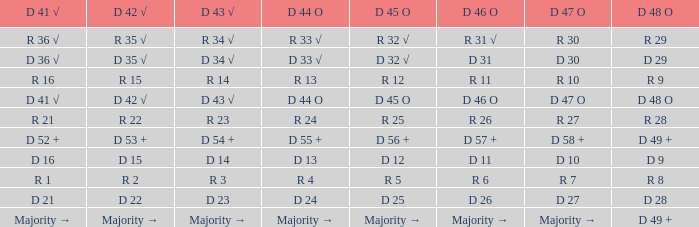Name the D 41 √ with D 44 O of r 13 R 16. Could you help me parse every detail presented in this table? {'header': ['D 41 √', 'D 42 √', 'D 43 √', 'D 44 O', 'D 45 O', 'D 46 O', 'D 47 O', 'D 48 O'], 'rows': [['R 36 √', 'R 35 √', 'R 34 √', 'R 33 √', 'R 32 √', 'R 31 √', 'R 30', 'R 29'], ['D 36 √', 'D 35 √', 'D 34 √', 'D 33 √', 'D 32 √', 'D 31', 'D 30', 'D 29'], ['R 16', 'R 15', 'R 14', 'R 13', 'R 12', 'R 11', 'R 10', 'R 9'], ['D 41 √', 'D 42 √', 'D 43 √', 'D 44 O', 'D 45 O', 'D 46 O', 'D 47 O', 'D 48 O'], ['R 21', 'R 22', 'R 23', 'R 24', 'R 25', 'R 26', 'R 27', 'R 28'], ['D 52 +', 'D 53 +', 'D 54 +', 'D 55 +', 'D 56 +', 'D 57 +', 'D 58 +', 'D 49 +'], ['D 16', 'D 15', 'D 14', 'D 13', 'D 12', 'D 11', 'D 10', 'D 9'], ['R 1', 'R 2', 'R 3', 'R 4', 'R 5', 'R 6', 'R 7', 'R 8'], ['D 21', 'D 22', 'D 23', 'D 24', 'D 25', 'D 26', 'D 27', 'D 28'], ['Majority →', 'Majority →', 'Majority →', 'Majority →', 'Majority →', 'Majority →', 'Majority →', 'D 49 +']]} 